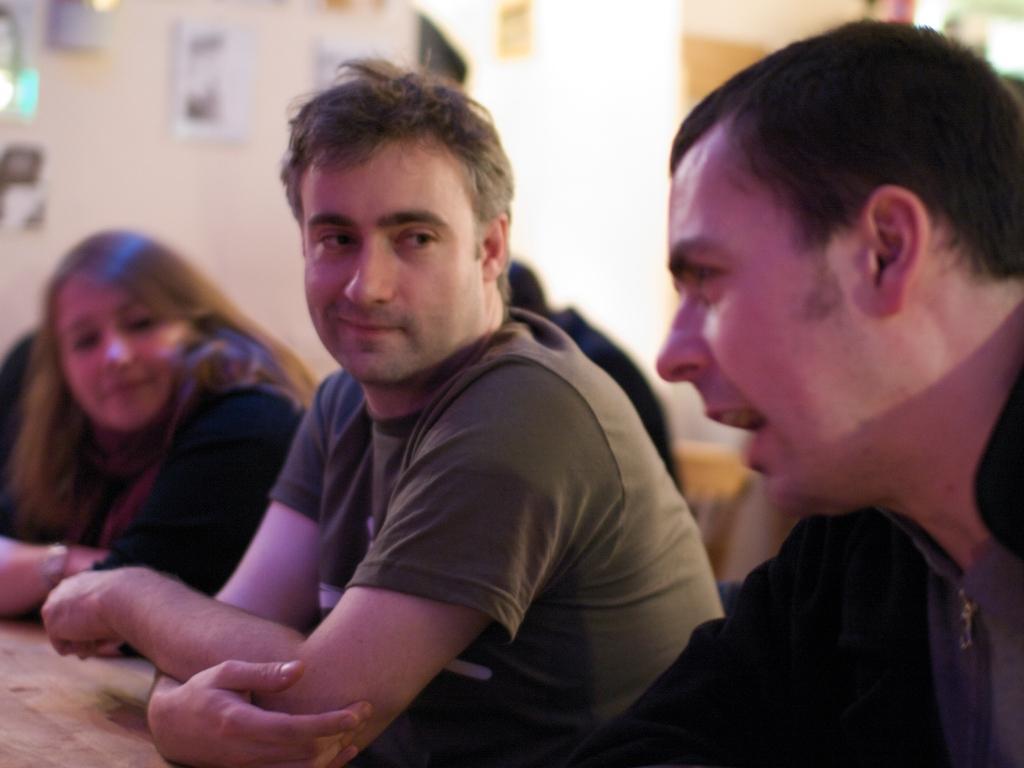Can you describe this image briefly? In this image I can see on the right side a man is there. He is speaking, in the middle there is another man. On the left side there is a woman, she wore black color top. 